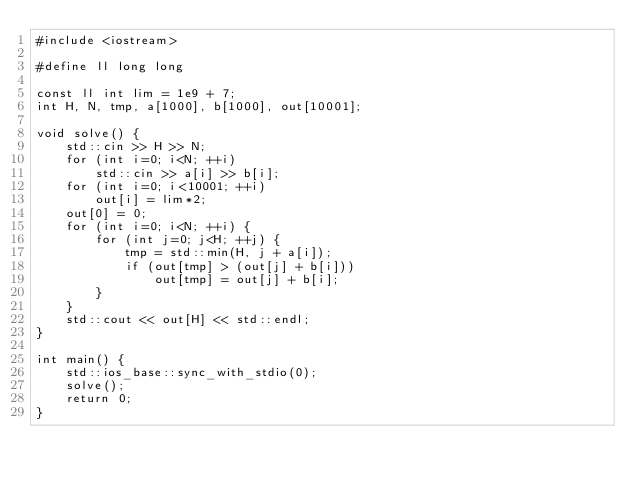Convert code to text. <code><loc_0><loc_0><loc_500><loc_500><_C++_>#include <iostream>

#define ll long long

const ll int lim = 1e9 + 7;
int H, N, tmp, a[1000], b[1000], out[10001];
 
void solve() {
    std::cin >> H >> N;
    for (int i=0; i<N; ++i)
        std::cin >> a[i] >> b[i];
    for (int i=0; i<10001; ++i)
        out[i] = lim*2;
    out[0] = 0;
    for (int i=0; i<N; ++i) {
        for (int j=0; j<H; ++j) {
            tmp = std::min(H, j + a[i]);
            if (out[tmp] > (out[j] + b[i]))
                out[tmp] = out[j] + b[i];
        }
    }
    std::cout << out[H] << std::endl;
}
 
int main() {
    std::ios_base::sync_with_stdio(0);
    solve();
    return 0;
}
</code> 